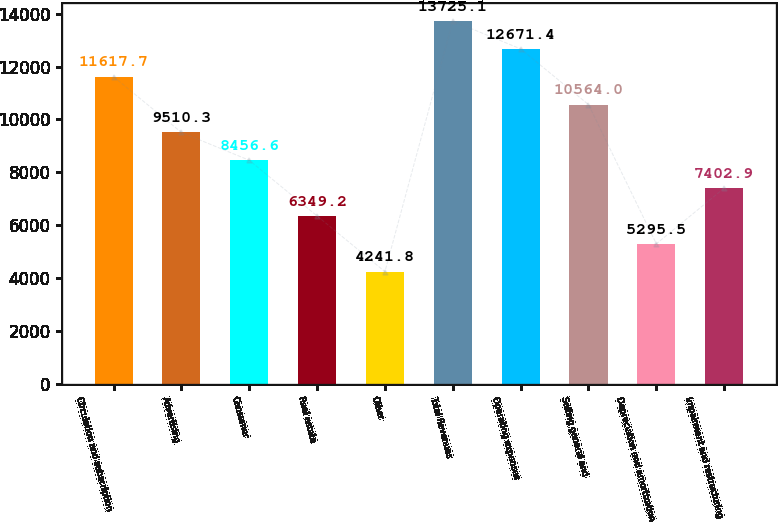<chart> <loc_0><loc_0><loc_500><loc_500><bar_chart><fcel>Circulation and subscription<fcel>Advertising<fcel>Consumer<fcel>Real estate<fcel>Other<fcel>Total Revenues<fcel>Operating expenses<fcel>Selling general and<fcel>Depreciation and amortization<fcel>Impairment and restructuring<nl><fcel>11617.7<fcel>9510.3<fcel>8456.6<fcel>6349.2<fcel>4241.8<fcel>13725.1<fcel>12671.4<fcel>10564<fcel>5295.5<fcel>7402.9<nl></chart> 